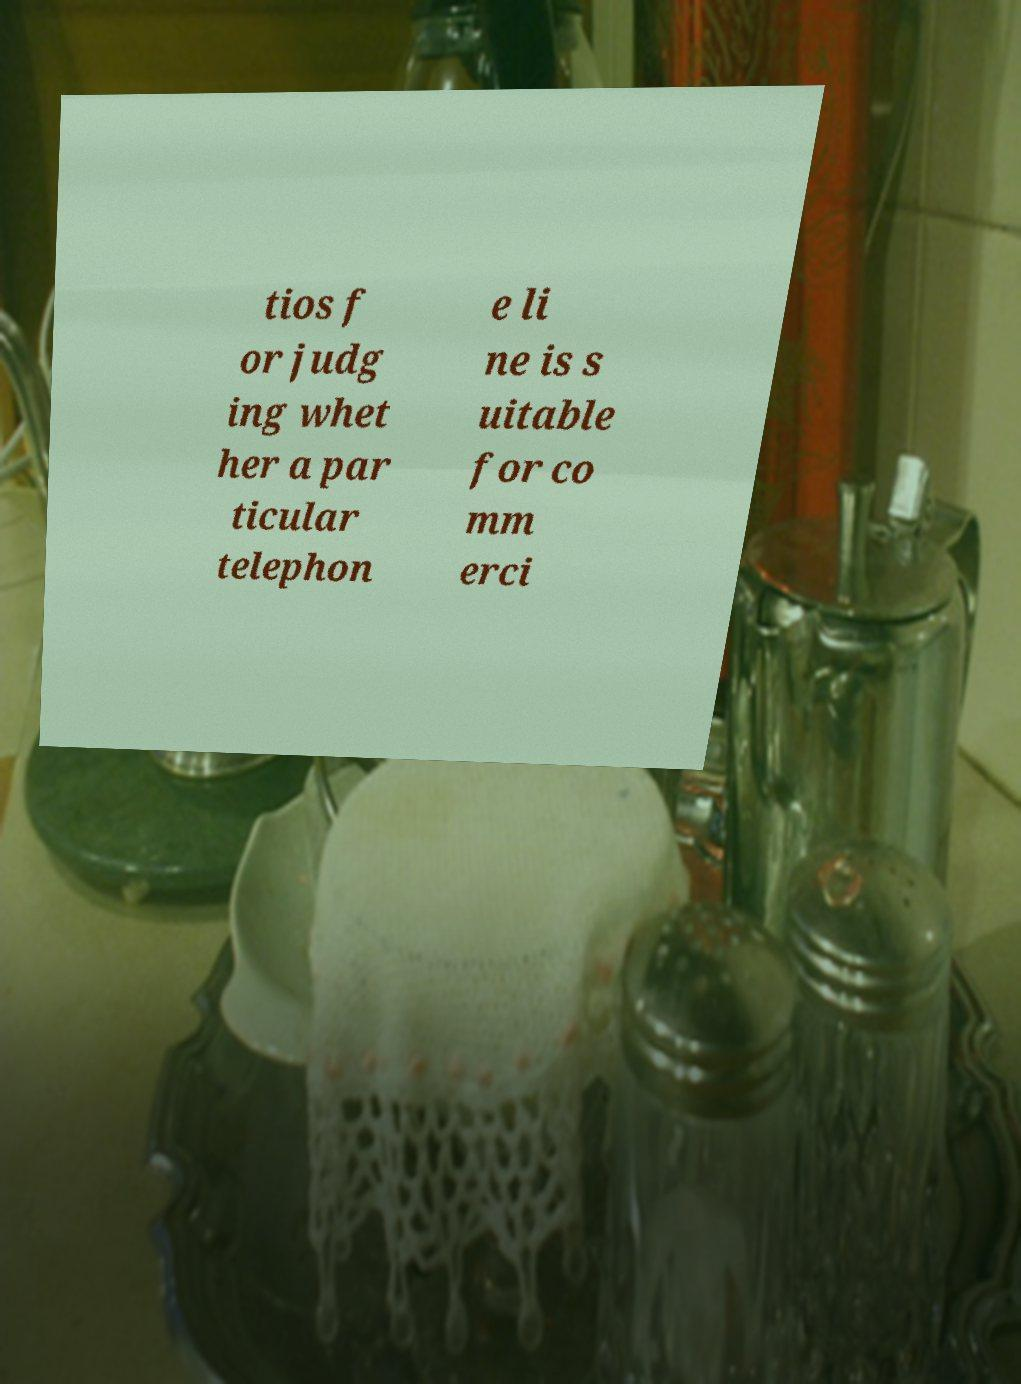I need the written content from this picture converted into text. Can you do that? tios f or judg ing whet her a par ticular telephon e li ne is s uitable for co mm erci 